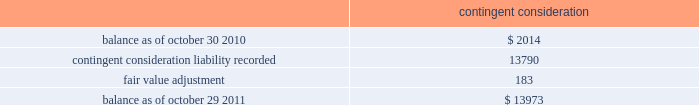( 2 ) the company has a master netting arrangement by counterparty with respect to derivative contracts .
As of october 29 , 2011 and october 30 , 2010 , contracts in a liability position of $ 0.8 million in each year , were netted against contracts in an asset position in the consolidated balance sheets .
( 3 ) equal to the accreted notional value of the debt plus the fair value of the interest rate component of the long- term debt .
The fair value of the long-term debt as of october 29 , 2011 and october 30 , 2010 was $ 413.4 million and $ 416.3 million , respectively .
The following methods and assumptions were used by the company in estimating its fair value disclosures for financial instruments : cash equivalents and short-term investments 2014 these investments are adjusted to fair value based on quoted market prices or are determined using a yield curve model based on current market rates .
Deferred compensation plan investments and other investments 2014 the fair value of these mutual fund , money market fund and equity investments are based on quoted market prices .
Long-term debt 2014 the fair value of long-term debt is based on quotes received from third-party banks .
Interest rate swap agreements 2014 the fair value of interest rate swap agreements is based on quotes received from third-party banks .
These values represent the estimated amount the company would receive or pay to terminate the agreements taking into consideration current interest rates as well as the creditworthiness of the counterparty .
Forward foreign currency exchange contracts 2014 the estimated fair value of forward foreign currency exchange contracts , which includes derivatives that are accounted for as cash flow hedges and those that are not designated as cash flow hedges , is based on the estimated amount the company would receive if it sold these agreements at the reporting date taking into consideration current interest rates as well as the creditworthiness of the counterparty for assets and the company 2019s creditworthiness for liabilities .
Contingent consideration 2014 the fair value of contingent consideration was estimated utilizing the income approach and is based upon significant inputs not observable in the market .
Changes in the fair value of the contingent consideration subsequent to the acquisition date that are primarily driven by assumptions pertaining to the achievement of the defined milestones will be recognized in operating income in the period of the estimated fair value change .
The table summarizes the change in the fair value of the contingent consideration measured using significant unobservable inputs ( level 3 ) for fiscal 2011 : contingent consideration .
Financial instruments not recorded at fair value on a recurring basis on april 4 , 2011 , the company issued $ 375 million aggregate principal amount of 3.0% ( 3.0 % ) senior unsecured notes due april 15 , 2016 ( the 3.0% ( 3.0 % ) notes ) with semi-annual fixed interest payments due on april 15 and october 15 of each year , commencing october 15 , 2011 .
The fair value of the 3.0% ( 3.0 % ) notes as of october 29 , 2011 was $ 392.8 million , based on quotes received from third-party banks .
Analog devices , inc .
Notes to consolidated financial statements 2014 ( continued ) .
What percentage of long-term debt was paid off from 2010 to 2011? 
Rationale: to find the percentage of long term debt paid off one must subtract the long term debt over the years then divide by the long-term debt in 2010 .
Computations: ((416.3 - 413.4) / 416.3)
Answer: 0.00697. 